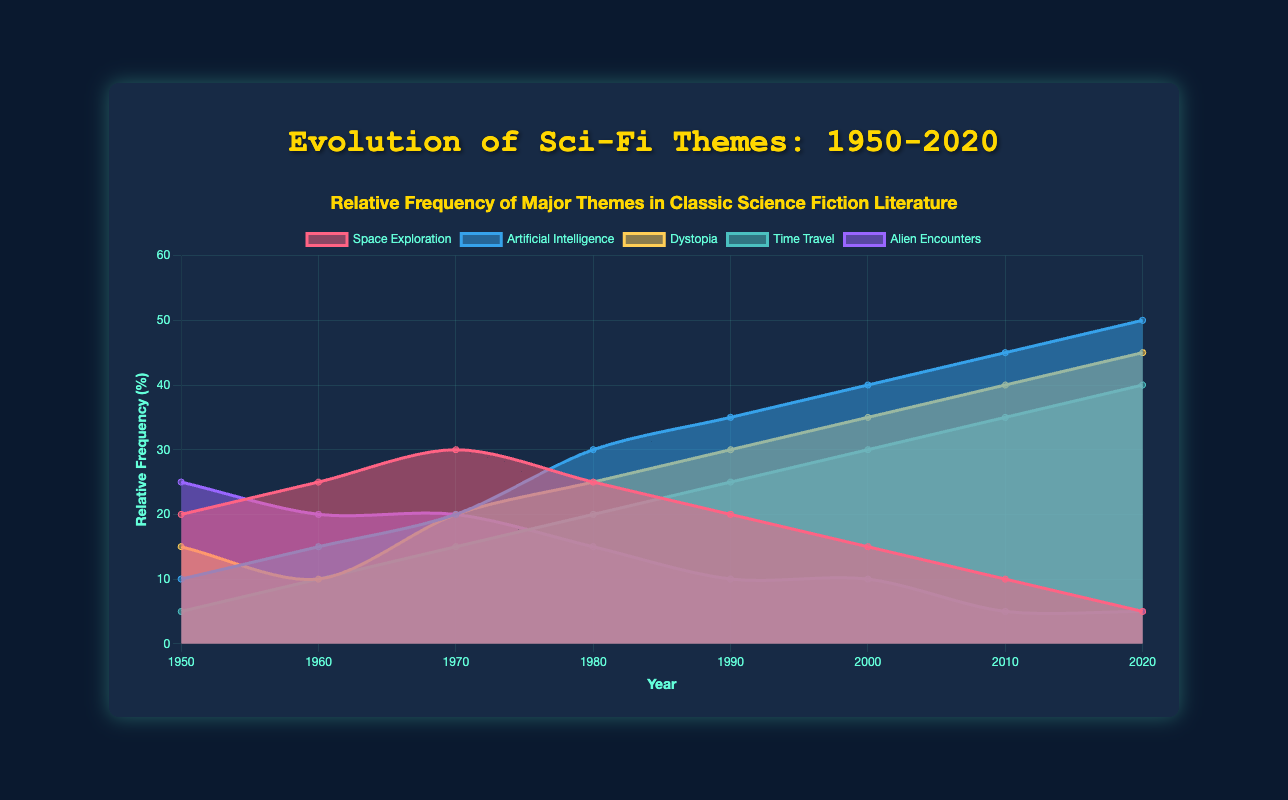Which theme had the highest relative frequency in 1950? In 1950, Alien Encounters had the highest relative frequency, which can be seen by checking the height of each theme's area segment at the 1950 mark on the x-axis.
Answer: Alien Encounters How did the relative frequency of Space Exploration change from 1950 to 2020? Space Exploration's relative frequency decreased from 20% in 1950 to 5% in 2020. This can be seen by comparing the heights of the Space Exploration segments at the 1950 and 2020 marks on the x-axis.
Answer: It decreased Which theme had the highest increase in relative frequency from 1980 to 2000? Compare the height increments of each theme's segments between 1980 and 2000. Artificial Intelligence increased from 30% to 40%, which is the largest increment of 10%.
Answer: Artificial Intelligence Which year saw the highest relative frequency for Dystopia? By looking at the Dystopia segment height across the x-axis timeline, Dystopia reached its peak relative frequency in 2020 at 45%.
Answer: 2020 Which theme had the most consistent relative frequency across all years? Time Travel increased steadily from 5% in 1950 to 40% in 2020 without major fluctuations. This can be deduced by observing the smooth upward trajectory of the Time Travel area over the years.
Answer: Time Travel What is the sum of the relative frequencies for Time Travel and Alien Encounters in 1990? The relative frequencies for Time Travel and Alien Encounters in 1990 are 25% and 10%, respectively. Adding these gives 25% + 10% = 35%.
Answer: 35% Which theme was less frequent in 1970 compared to 1960? Dystopia had a relative frequency of 10% in 1960 and increased to 20% in 1970. Hence, none of the themes fit.
Answer: None Which two themes showed a crossover point in their relative frequencies around 1980? By observing the overlapping segments, Space Exploration and Artificial Intelligence intersect around 1980, equalizing momentarily before diverging again.
Answer: Space Exploration and Artificial Intelligence How does the relative frequency of Artificial Intelligence in 1970 compare to that in 2020? In 1970, the relative frequency of Artificial Intelligence was 20%, while in 2020 it increased to 50%. By comparing the segment heights, we see that it more than doubled.
Answer: It more than doubled When did Space Exploration first become the least frequent theme? By comparing the heights of segments in each year, Space Exploration first became the least frequent theme in 2010.
Answer: 2010 